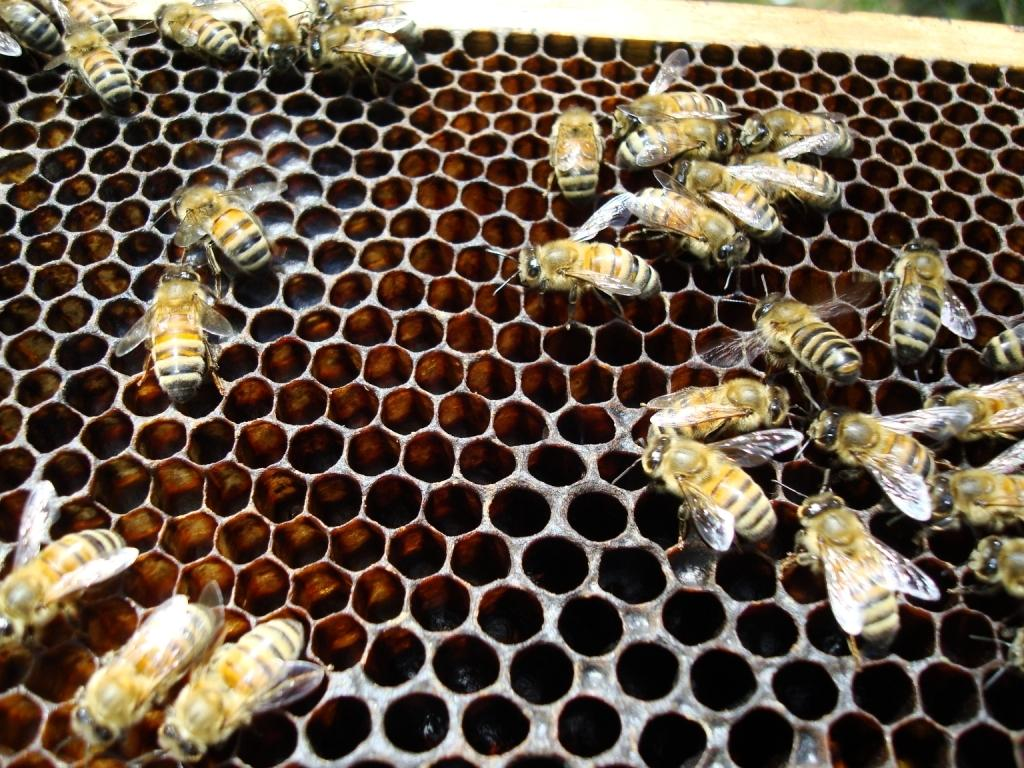What type of insects are present in the image? There are honey bees in the image. What color is the pear that the honey bees are pollinating in the image? There is no pear present in the image; it only features honey bees. 